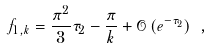Convert formula to latex. <formula><loc_0><loc_0><loc_500><loc_500>f _ { 1 , k } = \frac { \pi ^ { 2 } } { 3 } \tau _ { 2 } - \frac { \pi } { k } + \mathcal { O } \left ( e ^ { - \tau _ { 2 } } \right ) \ ,</formula> 